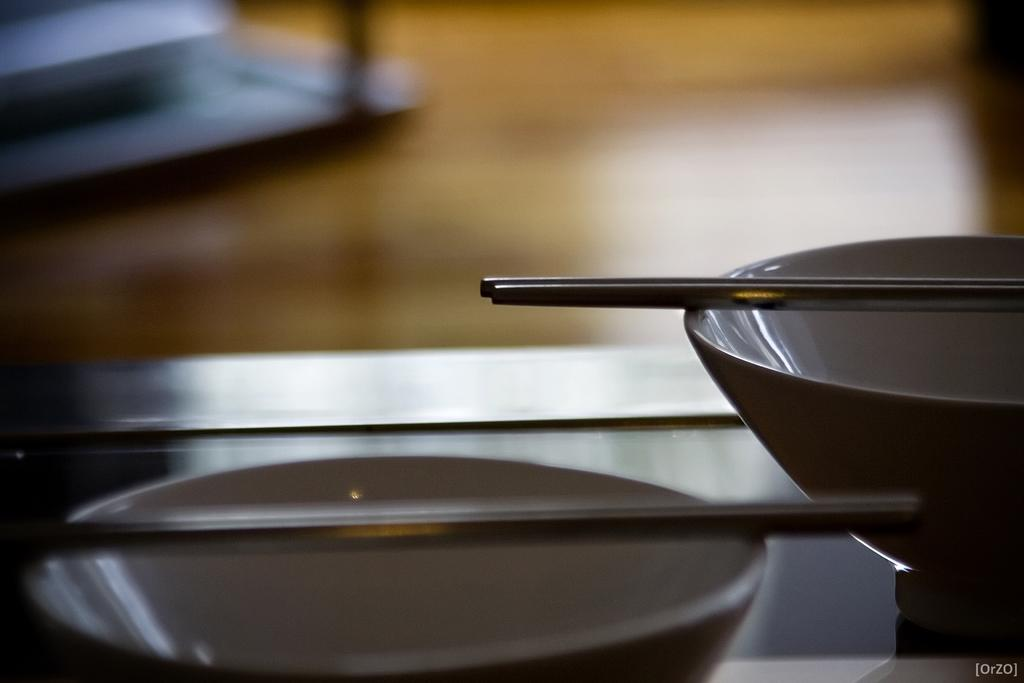What is located at the bottom of the image? There is a table at the bottom of the image. What objects are on the table? There are bowls and chopsticks on the table. What type of beetle can be seen crawling on the table in the image? There is no beetle present in the image; the table only has bowls and chopsticks on it. 